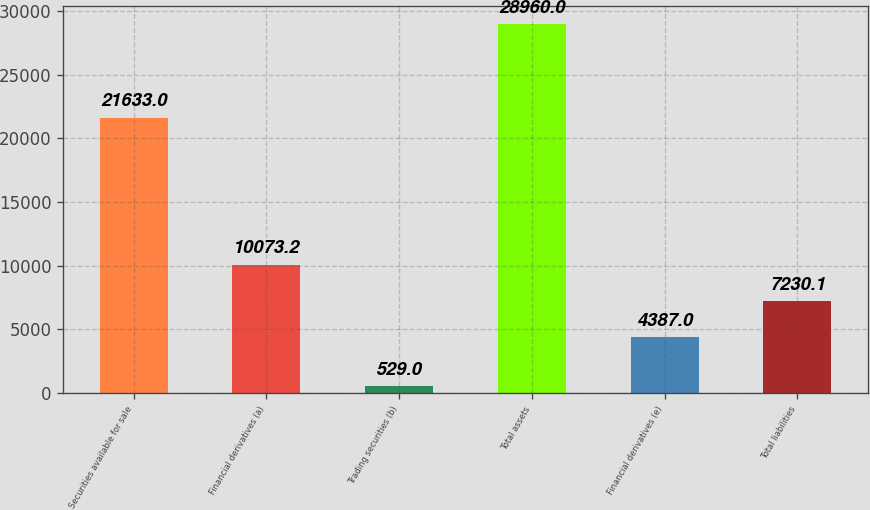Convert chart to OTSL. <chart><loc_0><loc_0><loc_500><loc_500><bar_chart><fcel>Securities available for sale<fcel>Financial derivatives (a)<fcel>Trading securities (b)<fcel>Total assets<fcel>Financial derivatives (e)<fcel>Total liabilities<nl><fcel>21633<fcel>10073.2<fcel>529<fcel>28960<fcel>4387<fcel>7230.1<nl></chart> 